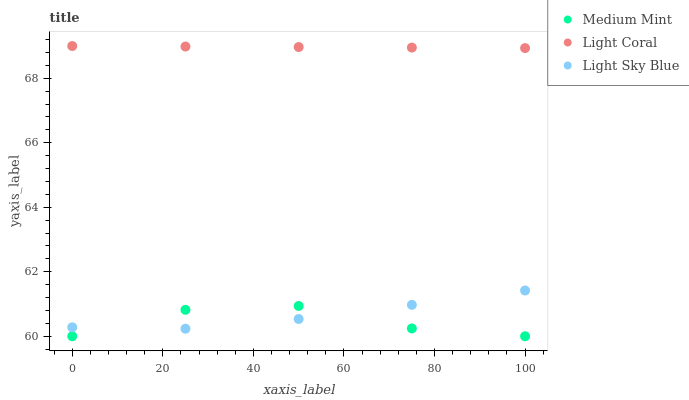Does Medium Mint have the minimum area under the curve?
Answer yes or no. Yes. Does Light Coral have the maximum area under the curve?
Answer yes or no. Yes. Does Light Sky Blue have the minimum area under the curve?
Answer yes or no. No. Does Light Sky Blue have the maximum area under the curve?
Answer yes or no. No. Is Light Coral the smoothest?
Answer yes or no. Yes. Is Medium Mint the roughest?
Answer yes or no. Yes. Is Light Sky Blue the smoothest?
Answer yes or no. No. Is Light Sky Blue the roughest?
Answer yes or no. No. Does Medium Mint have the lowest value?
Answer yes or no. Yes. Does Light Sky Blue have the lowest value?
Answer yes or no. No. Does Light Coral have the highest value?
Answer yes or no. Yes. Does Light Sky Blue have the highest value?
Answer yes or no. No. Is Medium Mint less than Light Coral?
Answer yes or no. Yes. Is Light Coral greater than Light Sky Blue?
Answer yes or no. Yes. Does Medium Mint intersect Light Sky Blue?
Answer yes or no. Yes. Is Medium Mint less than Light Sky Blue?
Answer yes or no. No. Is Medium Mint greater than Light Sky Blue?
Answer yes or no. No. Does Medium Mint intersect Light Coral?
Answer yes or no. No. 